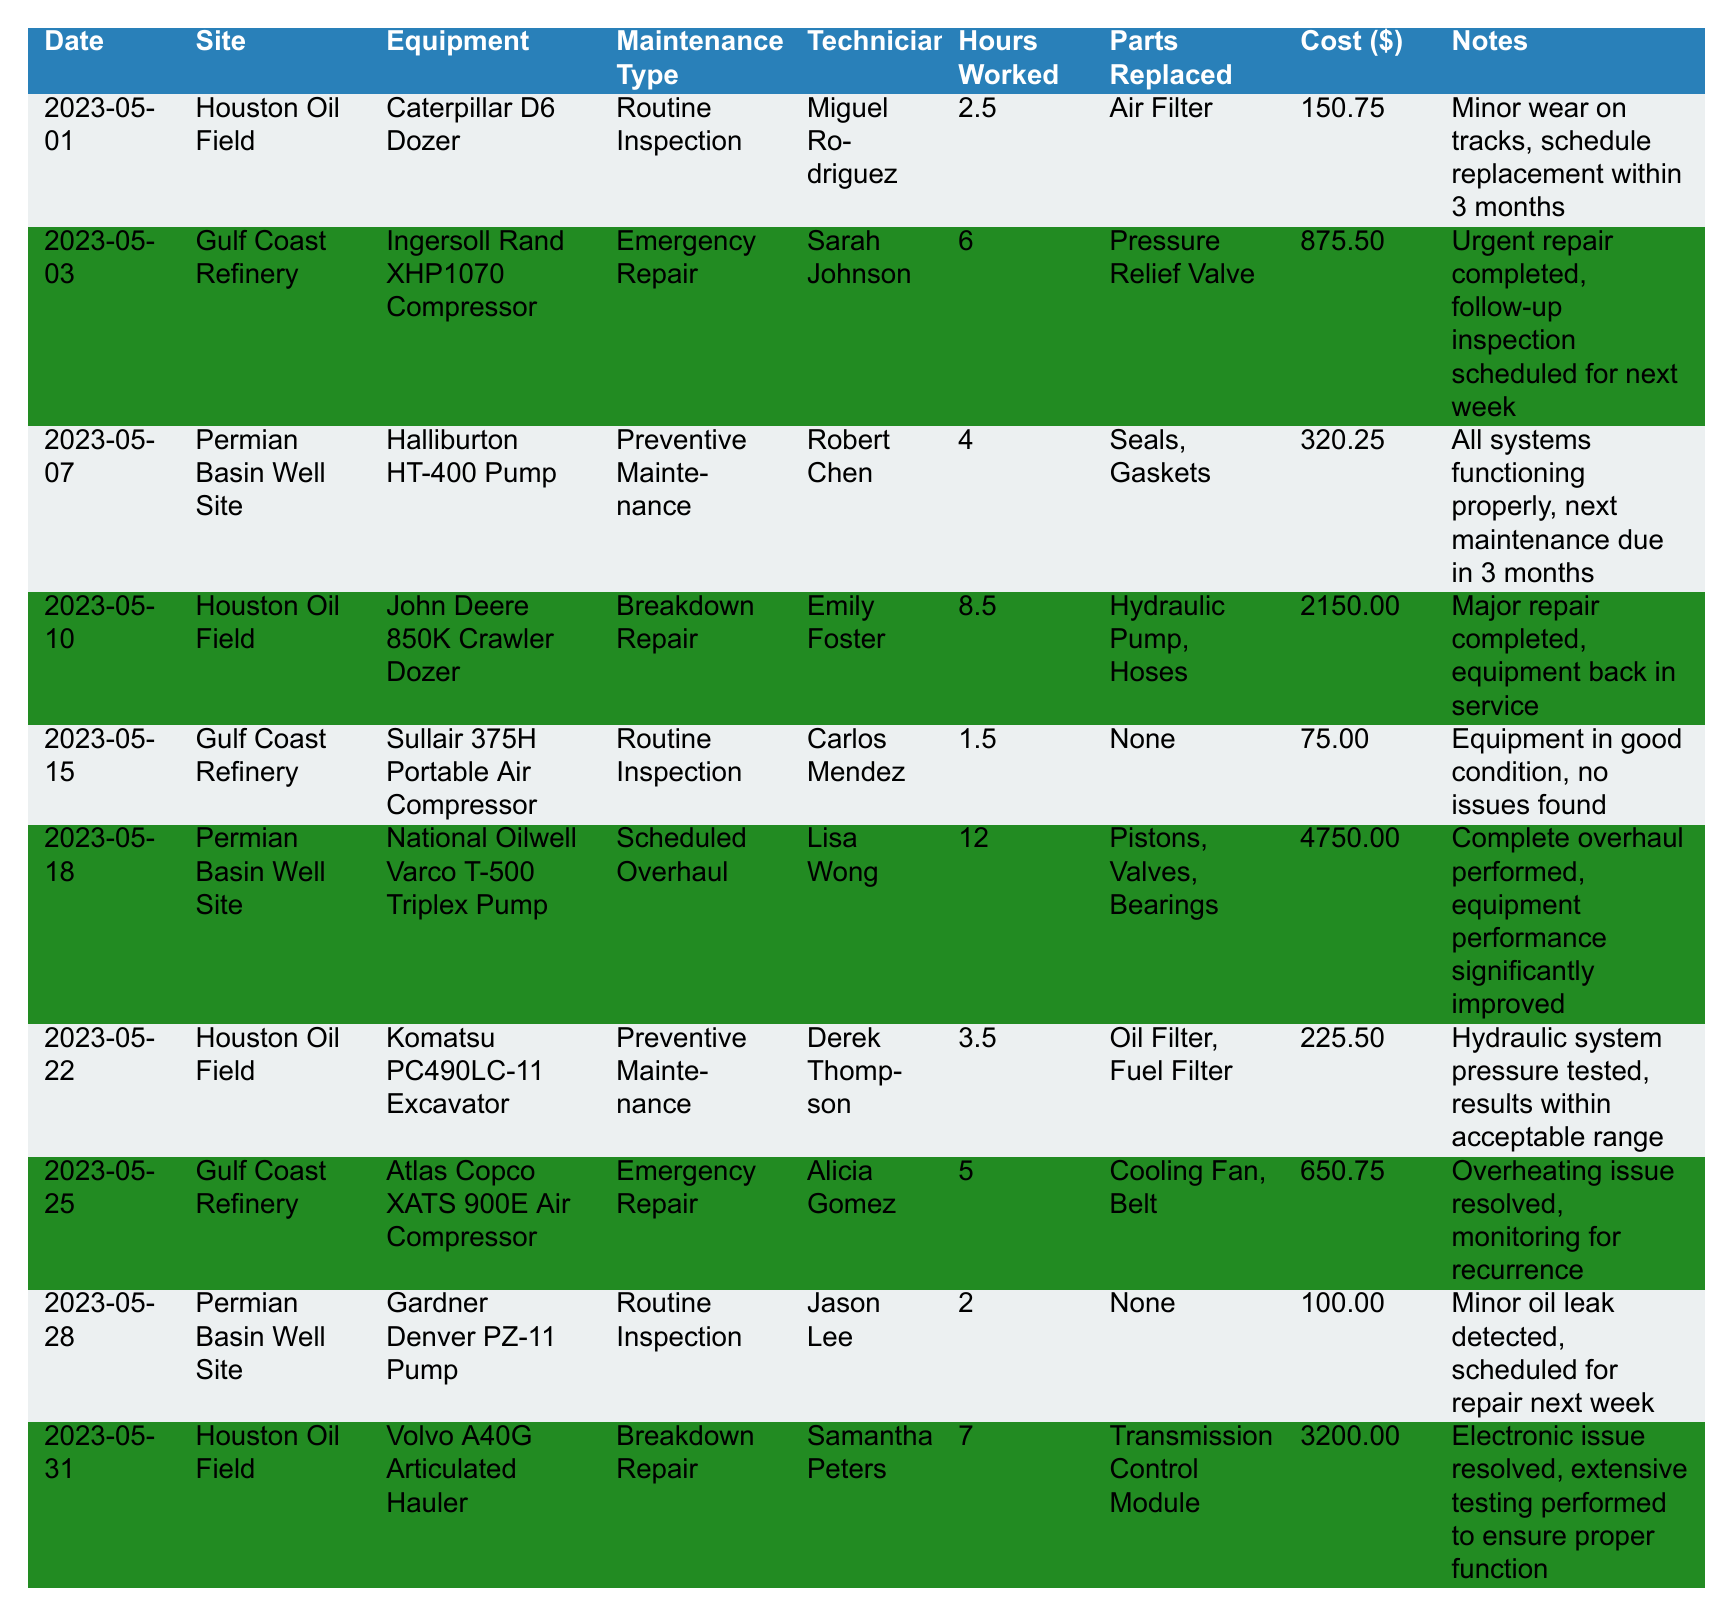What is the total cost of maintenance performed at the Gulf Coast Refinery? In the table, we can find the maintenance records at the Gulf Coast Refinery for May 3, May 15, and May 25. The costs are 875.50, 75.00, and 650.75 respectively. Adding these amounts gives: 875.50 + 75.00 + 650.75 = 1601.25.
Answer: 1601.25 Who performed the routine inspection at the Houston Oil Field on May 1? The table shows that Miguel Rodriguez conducted the routine inspection at the Houston Oil Field on May 1.
Answer: Miguel Rodriguez Did any maintenance occur on the National Oilwell Varco T-500 Triplex Pump at the Permian Basin Well Site? Yes, the table indicates that a scheduled overhaul was performed on the National Oilwell Varco T-500 Triplex Pump on May 18.
Answer: Yes What was the maximum number of hours worked for a single maintenance job? The highest hours worked listed in the table is 12 hours for the scheduled overhaul of the National Oilwell Varco T-500 Triplex Pump on May 18.
Answer: 12 How many pieces of equipment had routine inspections in total? The routine inspections were conducted on the Caterpillar D6 Dozer, Sullair 375H Portable Air Compressor, and Gardner Denver PZ-11 Pump. This totals to three routine inspections.
Answer: 3 What was the average cost for all emergency repairs done in May? There were two emergency repairs: the Ingersoll Rand XHP1070 Compressor for 875.50 and the Atlas Copco XATS 900E Air Compressor for 650.75. Their total cost is 875.50 + 650.75 = 1526.25. The average cost is then 1526.25 / 2 = 763.125.
Answer: 763.125 Was the Komatsu PC490LC-11 Excavator subjected to any breakdown repair? No, the maintenance record for the Komatsu PC490LC-11 Excavator on May 22 indicates that it underwent preventive maintenance, not breakdown repair.
Answer: No Who worked the most hours on a single piece of equipment? Emily Foster worked the most hours, totaling 8.5 hours on the breakdown repair of the John Deere 850K Crawler Dozer.
Answer: Emily Foster What percentage of maintenance tasks were categorized as preventive maintenance? There are three preventive maintenance tasks (Halliburton HT-400 Pump, Komatsu PC490LC-11 Excavator, and one other). There are a total of ten entries, so: (3 / 10) * 100 = 30%.
Answer: 30% How many different technicians were involved in the maintenance jobs? The table lists 9 unique technicians: Miguel Rodriguez, Sarah Johnson, Robert Chen, Emily Foster, Carlos Mendez, Lisa Wong, Derek Thompson, Alicia Gomez, and Samantha Peters. Thus, there are 9 technicians.
Answer: 9 What maintenance type was performed the most times across all sites? Preventive maintenance and routine inspections were performed 3 times each, while emergency repairs and breakdown repairs occurred fewer times. Since both preventive and routine happened equally, we can say: these two types are the most performed maintenance types.
Answer: Preventive and routine inspections 